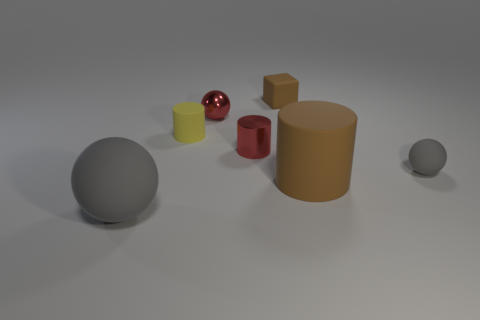How many other objects are the same color as the large rubber cylinder? 1 